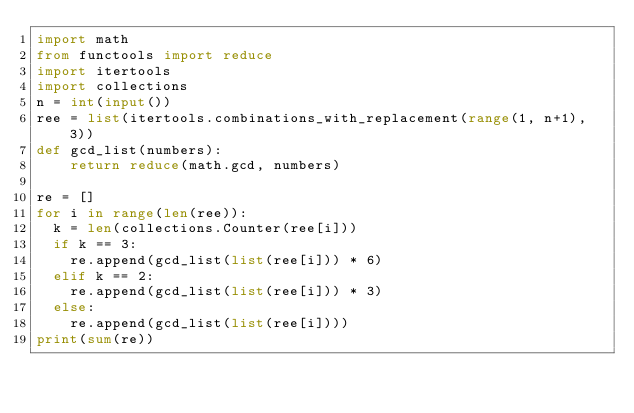Convert code to text. <code><loc_0><loc_0><loc_500><loc_500><_Python_>import math
from functools import reduce
import itertools
import collections
n = int(input())
ree = list(itertools.combinations_with_replacement(range(1, n+1), 3))
def gcd_list(numbers):
    return reduce(math.gcd, numbers)

re = []
for i in range(len(ree)):
  k = len(collections.Counter(ree[i]))
  if k == 3:
    re.append(gcd_list(list(ree[i])) * 6)
  elif k == 2:
    re.append(gcd_list(list(ree[i])) * 3)
  else:
    re.append(gcd_list(list(ree[i])))
print(sum(re))
</code> 